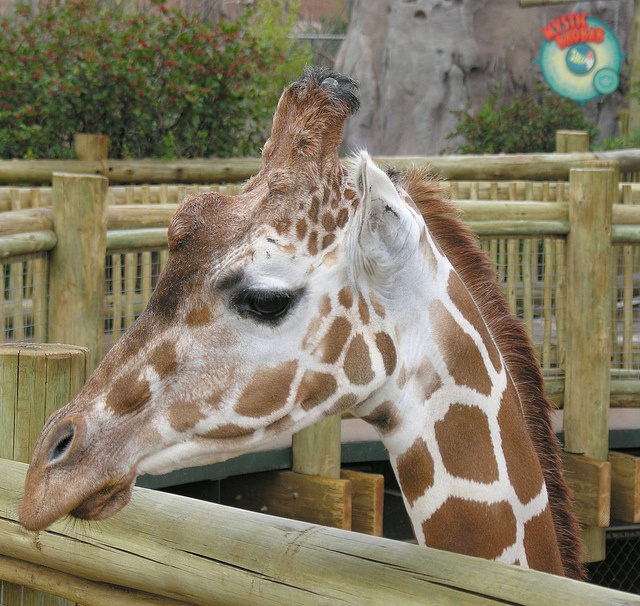Describe the objects in this image and their specific colors. I can see a giraffe in gray, darkgray, lightgray, and brown tones in this image. 